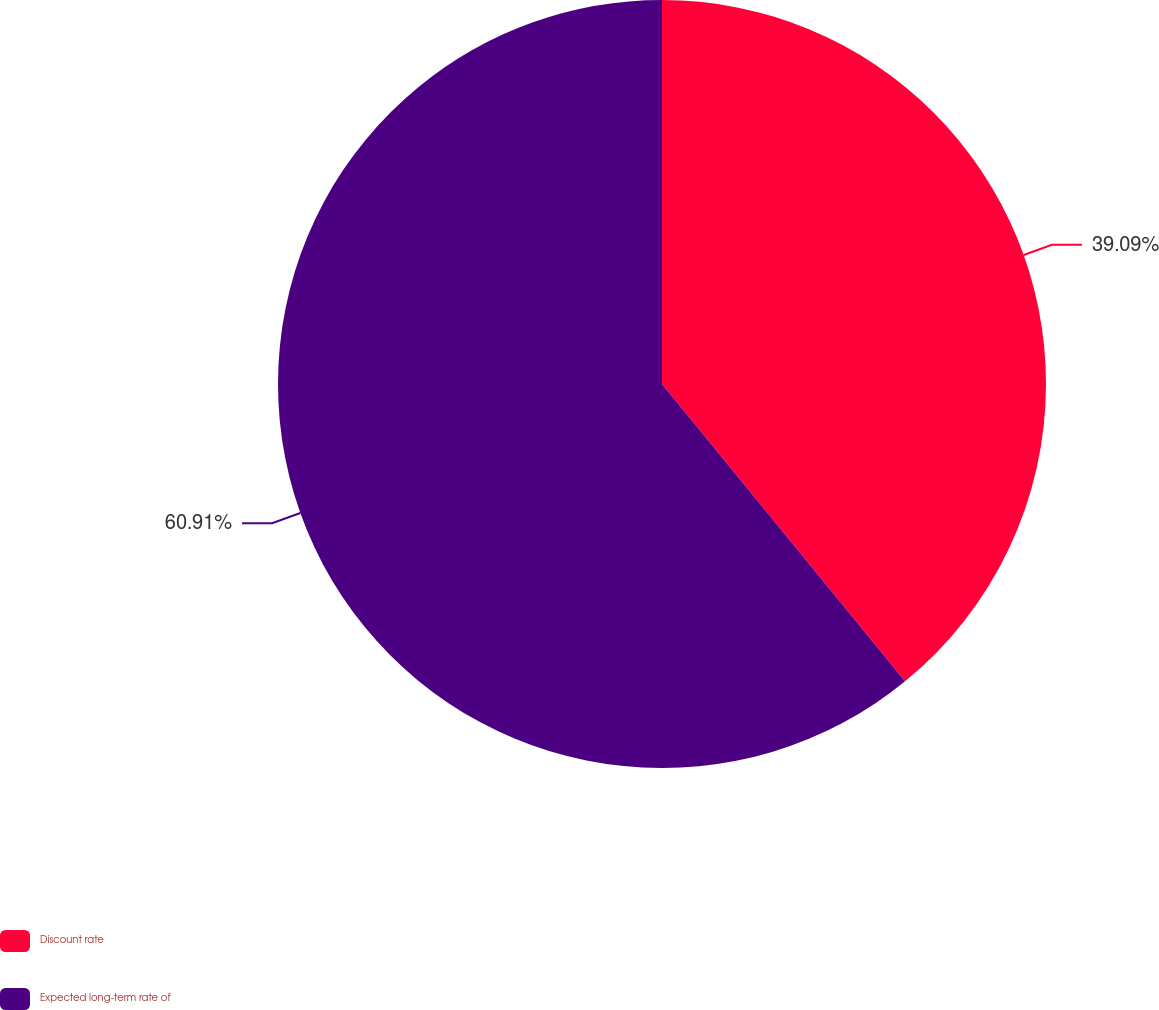Convert chart to OTSL. <chart><loc_0><loc_0><loc_500><loc_500><pie_chart><fcel>Discount rate<fcel>Expected long-term rate of<nl><fcel>39.09%<fcel>60.91%<nl></chart> 